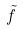Convert formula to latex. <formula><loc_0><loc_0><loc_500><loc_500>\tilde { f }</formula> 